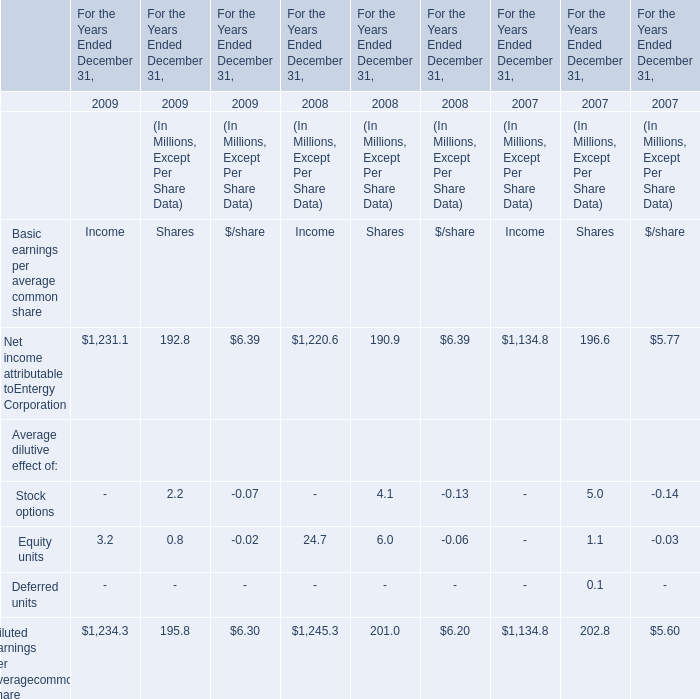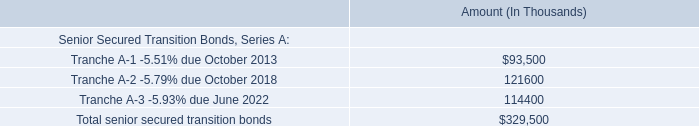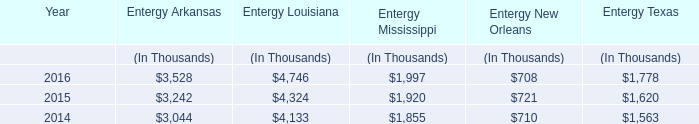What is the sum of Net income attributable to Entergy Corporation in the range of 7 and 1232 in 2009? (in million) 
Computations: (1231.1 + 192.8)
Answer: 1423.9. 